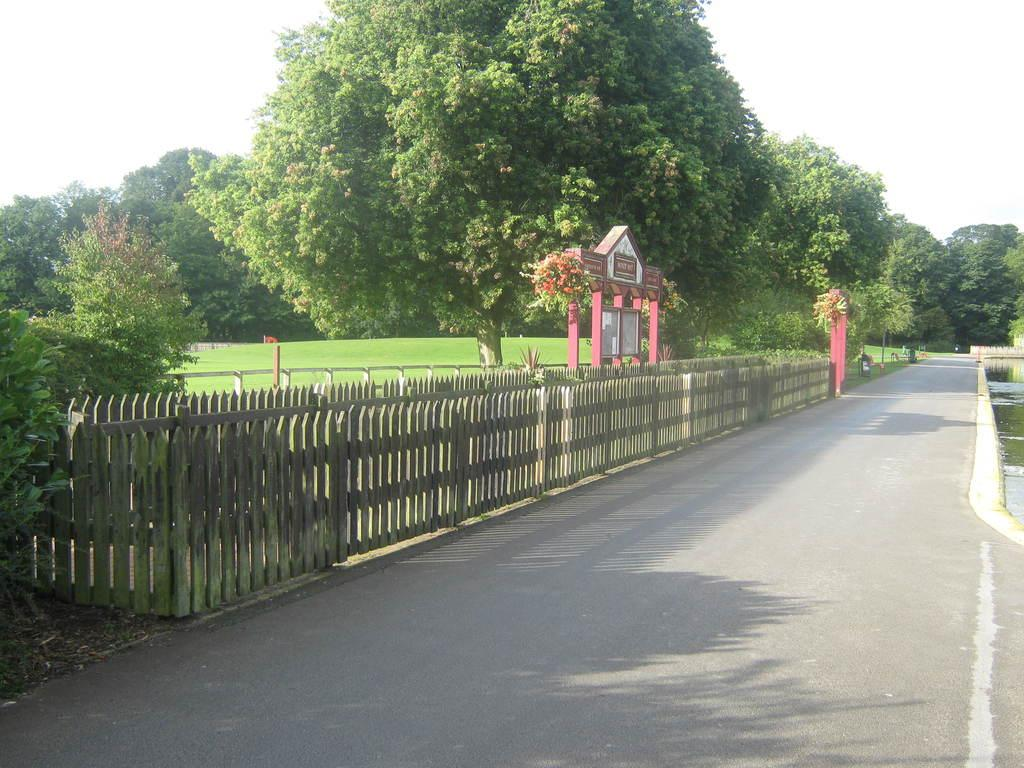What is the main feature of the image? There is a road in the image. What can be seen in the background of the image? There is fencing, trees, and the sky visible in the background of the image. What type of punishment is being handed out in the image? There is no indication of punishment in the image; it only features a road and elements in the background. 